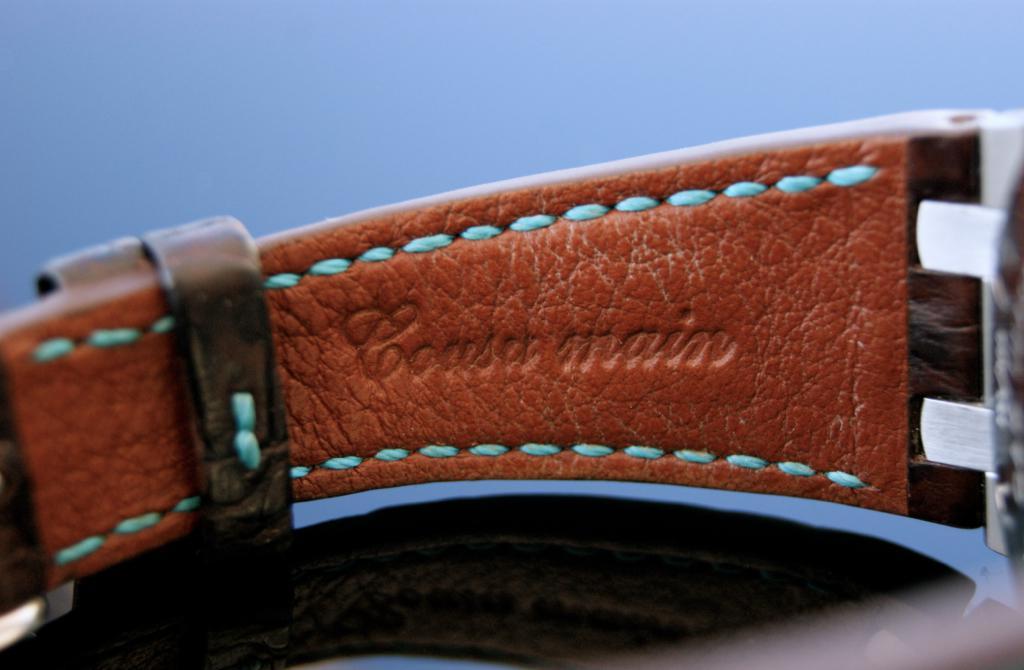What does the text on the leather say?
Make the answer very short. Coast main. What brand is this?
Provide a short and direct response. Coasa main. 